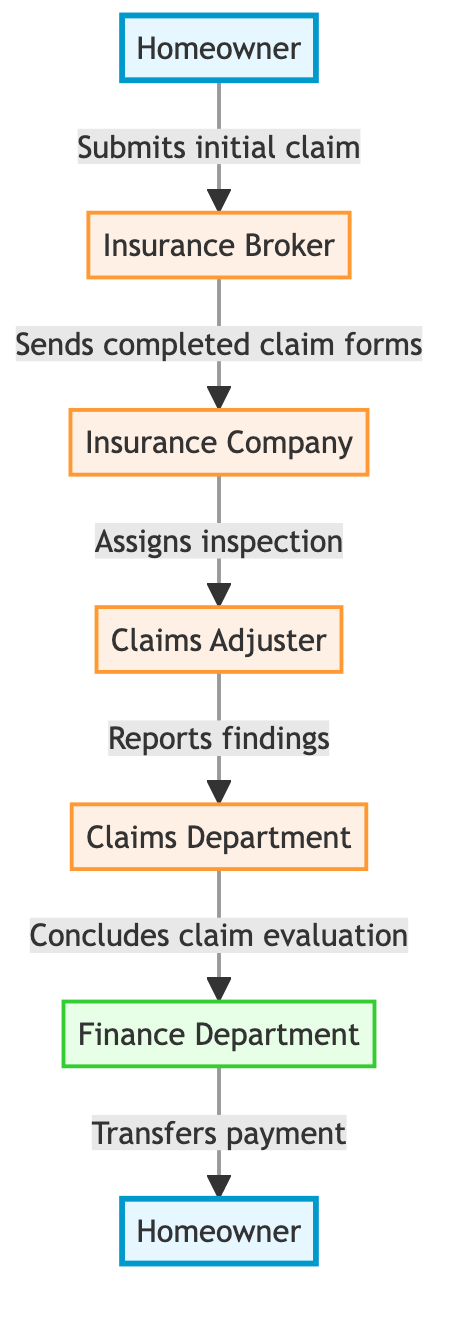What is the first step in the home insurance claim process? The first step is denoted by the arrow leading from the Homeowner to the Insurance Broker, indicating that the homeowner submits the initial claim.
Answer: Submits initial claim How many departments are involved in the claim settlement process? By examining the diagram, we can see that there are three departments involved: Insurance Company, Claims Department, and Finance Department.
Answer: Three Who receives the completed claim forms after the Insurance Broker? Following the flow from the Insurance Broker, the completed claim forms are sent to the Insurance Company as shown in the diagram.
Answer: Insurance Company What does the Claims Adjuster do after being assigned? The Claims Adjuster reports findings to the Claims Department after conducting the necessary inspections as indicated in the flow.
Answer: Reports findings What is the final action taken in the claim settlement process? The final action is represented by the Finance Department transferring payment to the homeowner, which is the last step in the flow.
Answer: Transfers payment What is the role of the Claims Department? The Claims Department concludes the claim evaluation, which is a crucial part of the entire claims process.
Answer: Concludes claim evaluation After the Claims Adjuster reports findings, who is the next point of contact? The findings reported by the Claims Adjuster go directly to the Claims Department, making them the next point of contact.
Answer: Claims Department Which entity assigns the inspection? The diagram shows that the process of assigning the inspection is the responsibility of the Insurance Company, as indicated in the flow.
Answer: Insurance Company Where does the homeowner appear in the flowchart? The homeowner appears at the beginning and the end of the flowchart, highlighting their involvement in both submitting the claim and receiving the payment.
Answer: At the beginning and end 